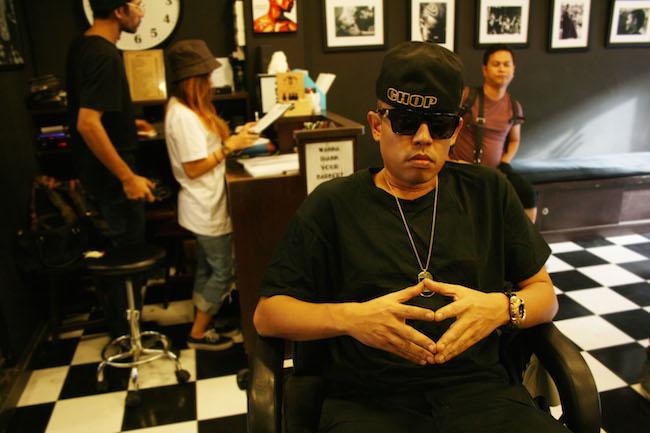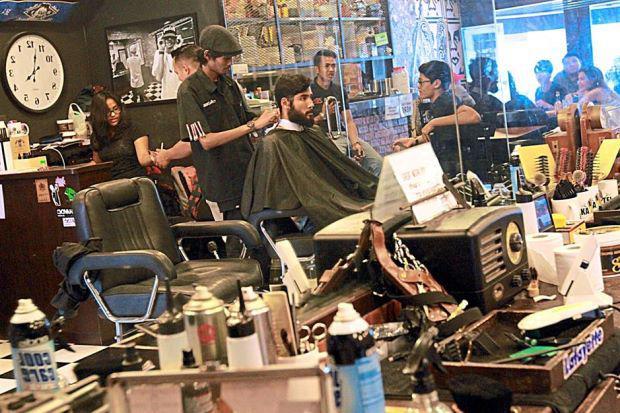The first image is the image on the left, the second image is the image on the right. Given the left and right images, does the statement "In the left image the person furthest to the left is cutting another persons hair that is seated in a barbers chair." hold true? Answer yes or no. No. The first image is the image on the left, the second image is the image on the right. Examine the images to the left and right. Is the description "There is a TV mounted high on the wall  in a barbershop with at least three barber chairs available to sit in." accurate? Answer yes or no. No. 